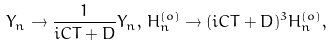Convert formula to latex. <formula><loc_0><loc_0><loc_500><loc_500>Y _ { n } \rightarrow \frac { 1 } { i C T + D } Y _ { n } , \, H _ { n } ^ { ( o ) } \rightarrow ( i C T + D ) ^ { 3 } H _ { n } ^ { ( o ) } ,</formula> 